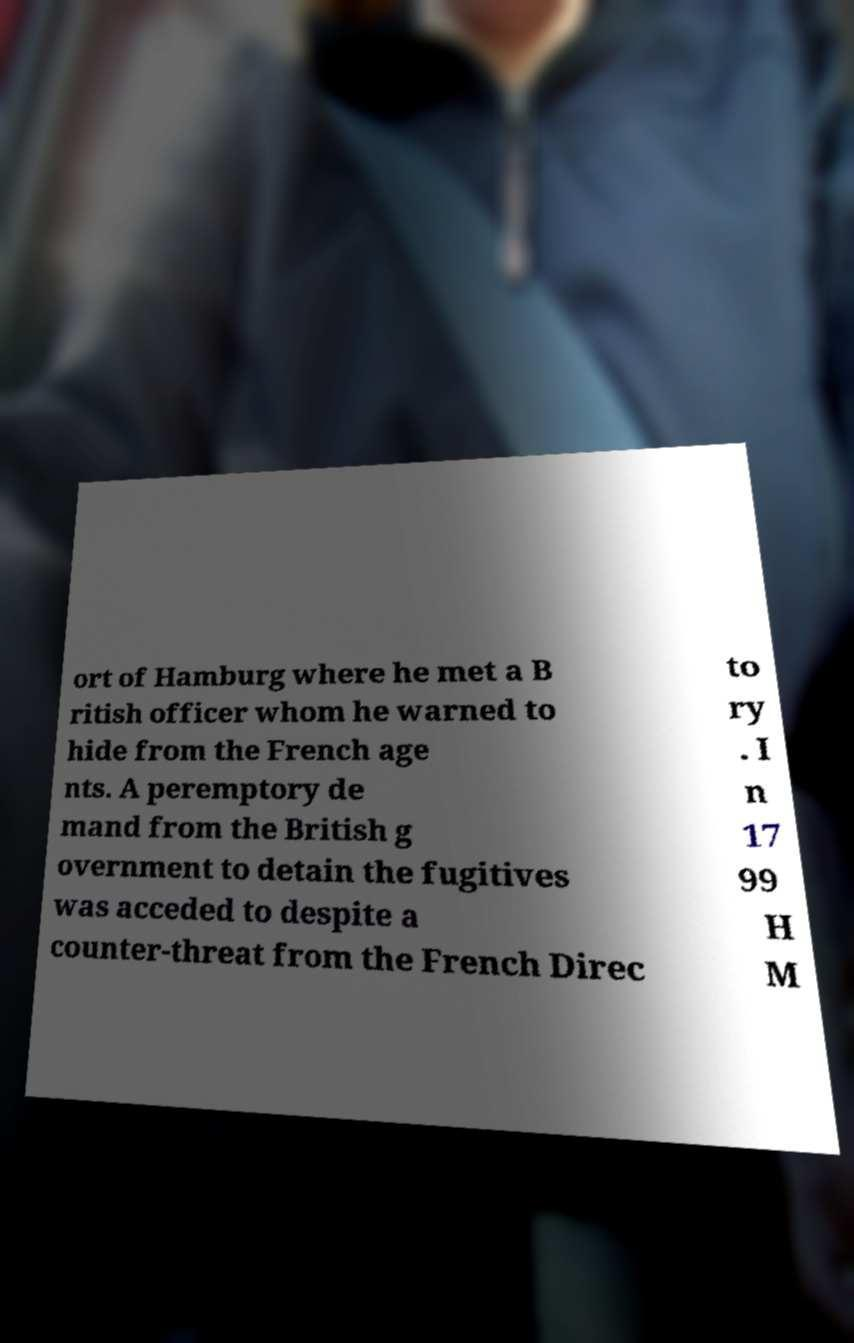Could you extract and type out the text from this image? ort of Hamburg where he met a B ritish officer whom he warned to hide from the French age nts. A peremptory de mand from the British g overnment to detain the fugitives was acceded to despite a counter-threat from the French Direc to ry . I n 17 99 H M 